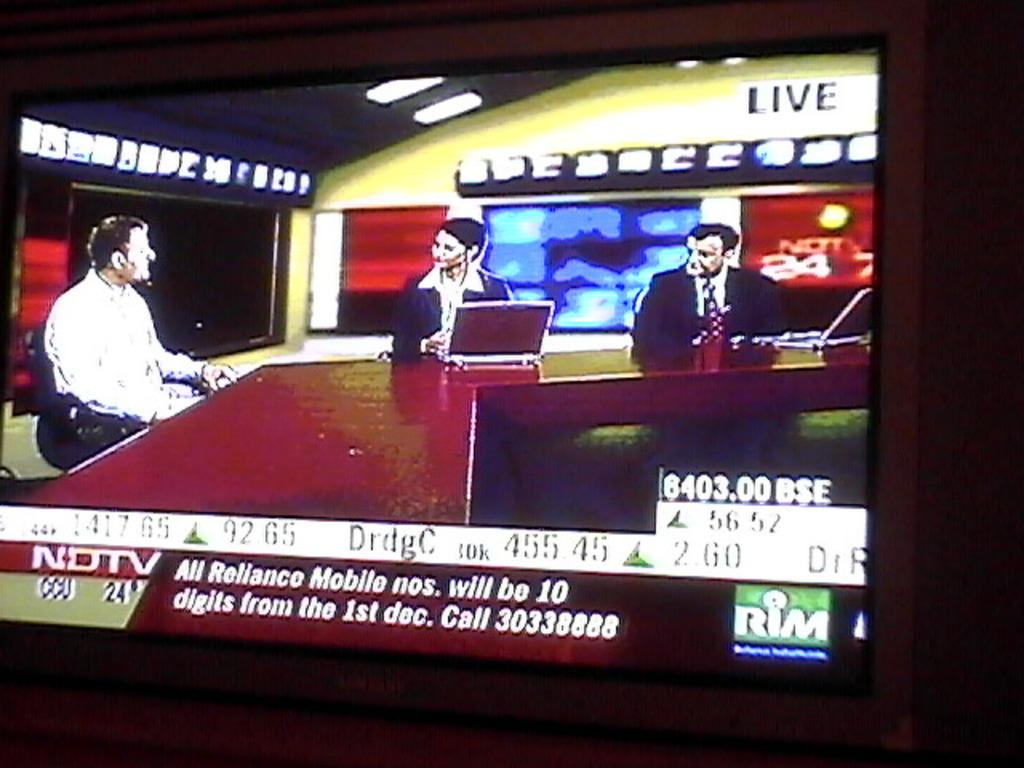<image>
Render a clear and concise summary of the photo. A live broadcast on NDTV about how All reliance mobile numbers will be 10 digits 